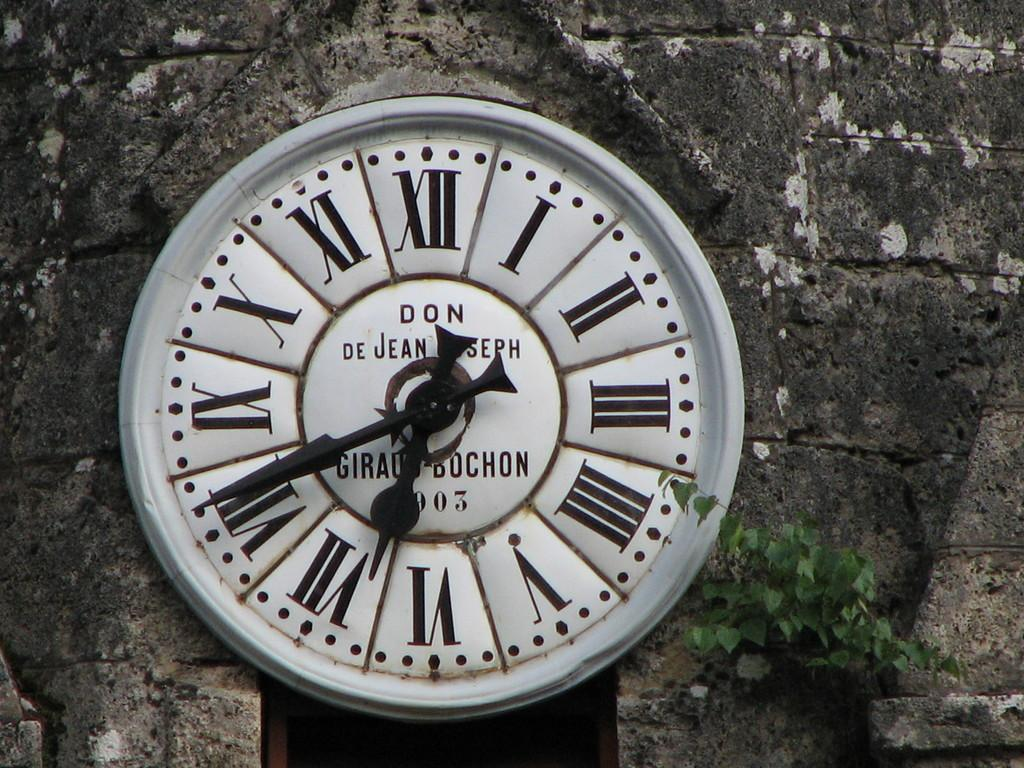<image>
Present a compact description of the photo's key features. A clock with Roman numerals pointing to twenty to seven. 